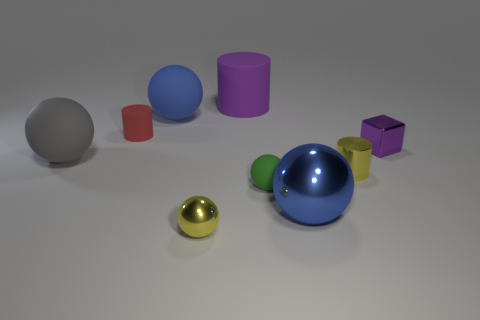What materials seem to be represented by the objects in the image? The image showcases objects that resemble materials such as matte and shiny plastics, rubber, and metal. The large gray sphere has a matte finish possibly imitating stone, the green and yellow objects look like shiny plastic, the small red and purple objects appear to be of a matte rubbery texture, and the small reflective gold object might be representing metal. 